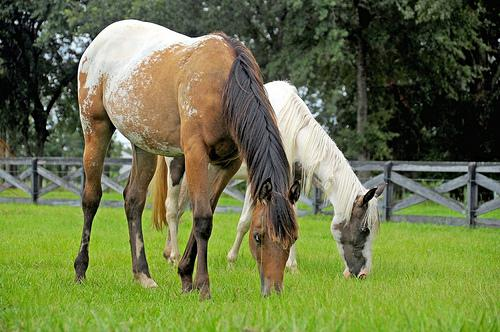Question: what color is the grass?
Choices:
A. Black.
B. Brown.
C. Green.
D. Yellow.
Answer with the letter. Answer: C Question: who is in this picture?
Choices:
A. Puppies.
B. Kittens.
C. Four ducks.
D. Two horses.
Answer with the letter. Answer: D Question: why are the horses heads to the ground?
Choices:
A. Drinking.
B. They are eating.
C. Grazing.
D. They have a neck ache.
Answer with the letter. Answer: B Question: what color is the closest horse?
Choices:
A. Tan.
B. Brown.
C. Black.
D. White.
Answer with the letter. Answer: A 